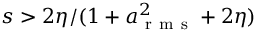<formula> <loc_0><loc_0><loc_500><loc_500>s > 2 \eta / ( 1 + a _ { r m s } ^ { 2 } + 2 \eta )</formula> 